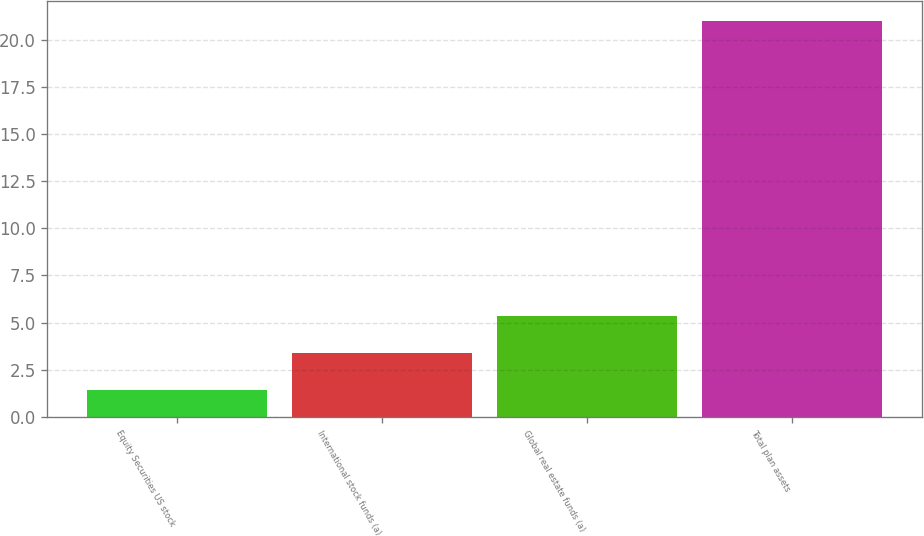<chart> <loc_0><loc_0><loc_500><loc_500><bar_chart><fcel>Equity Securities US stock<fcel>International stock funds (a)<fcel>Global real estate funds (a)<fcel>Total plan assets<nl><fcel>1.44<fcel>3.4<fcel>5.36<fcel>21<nl></chart> 